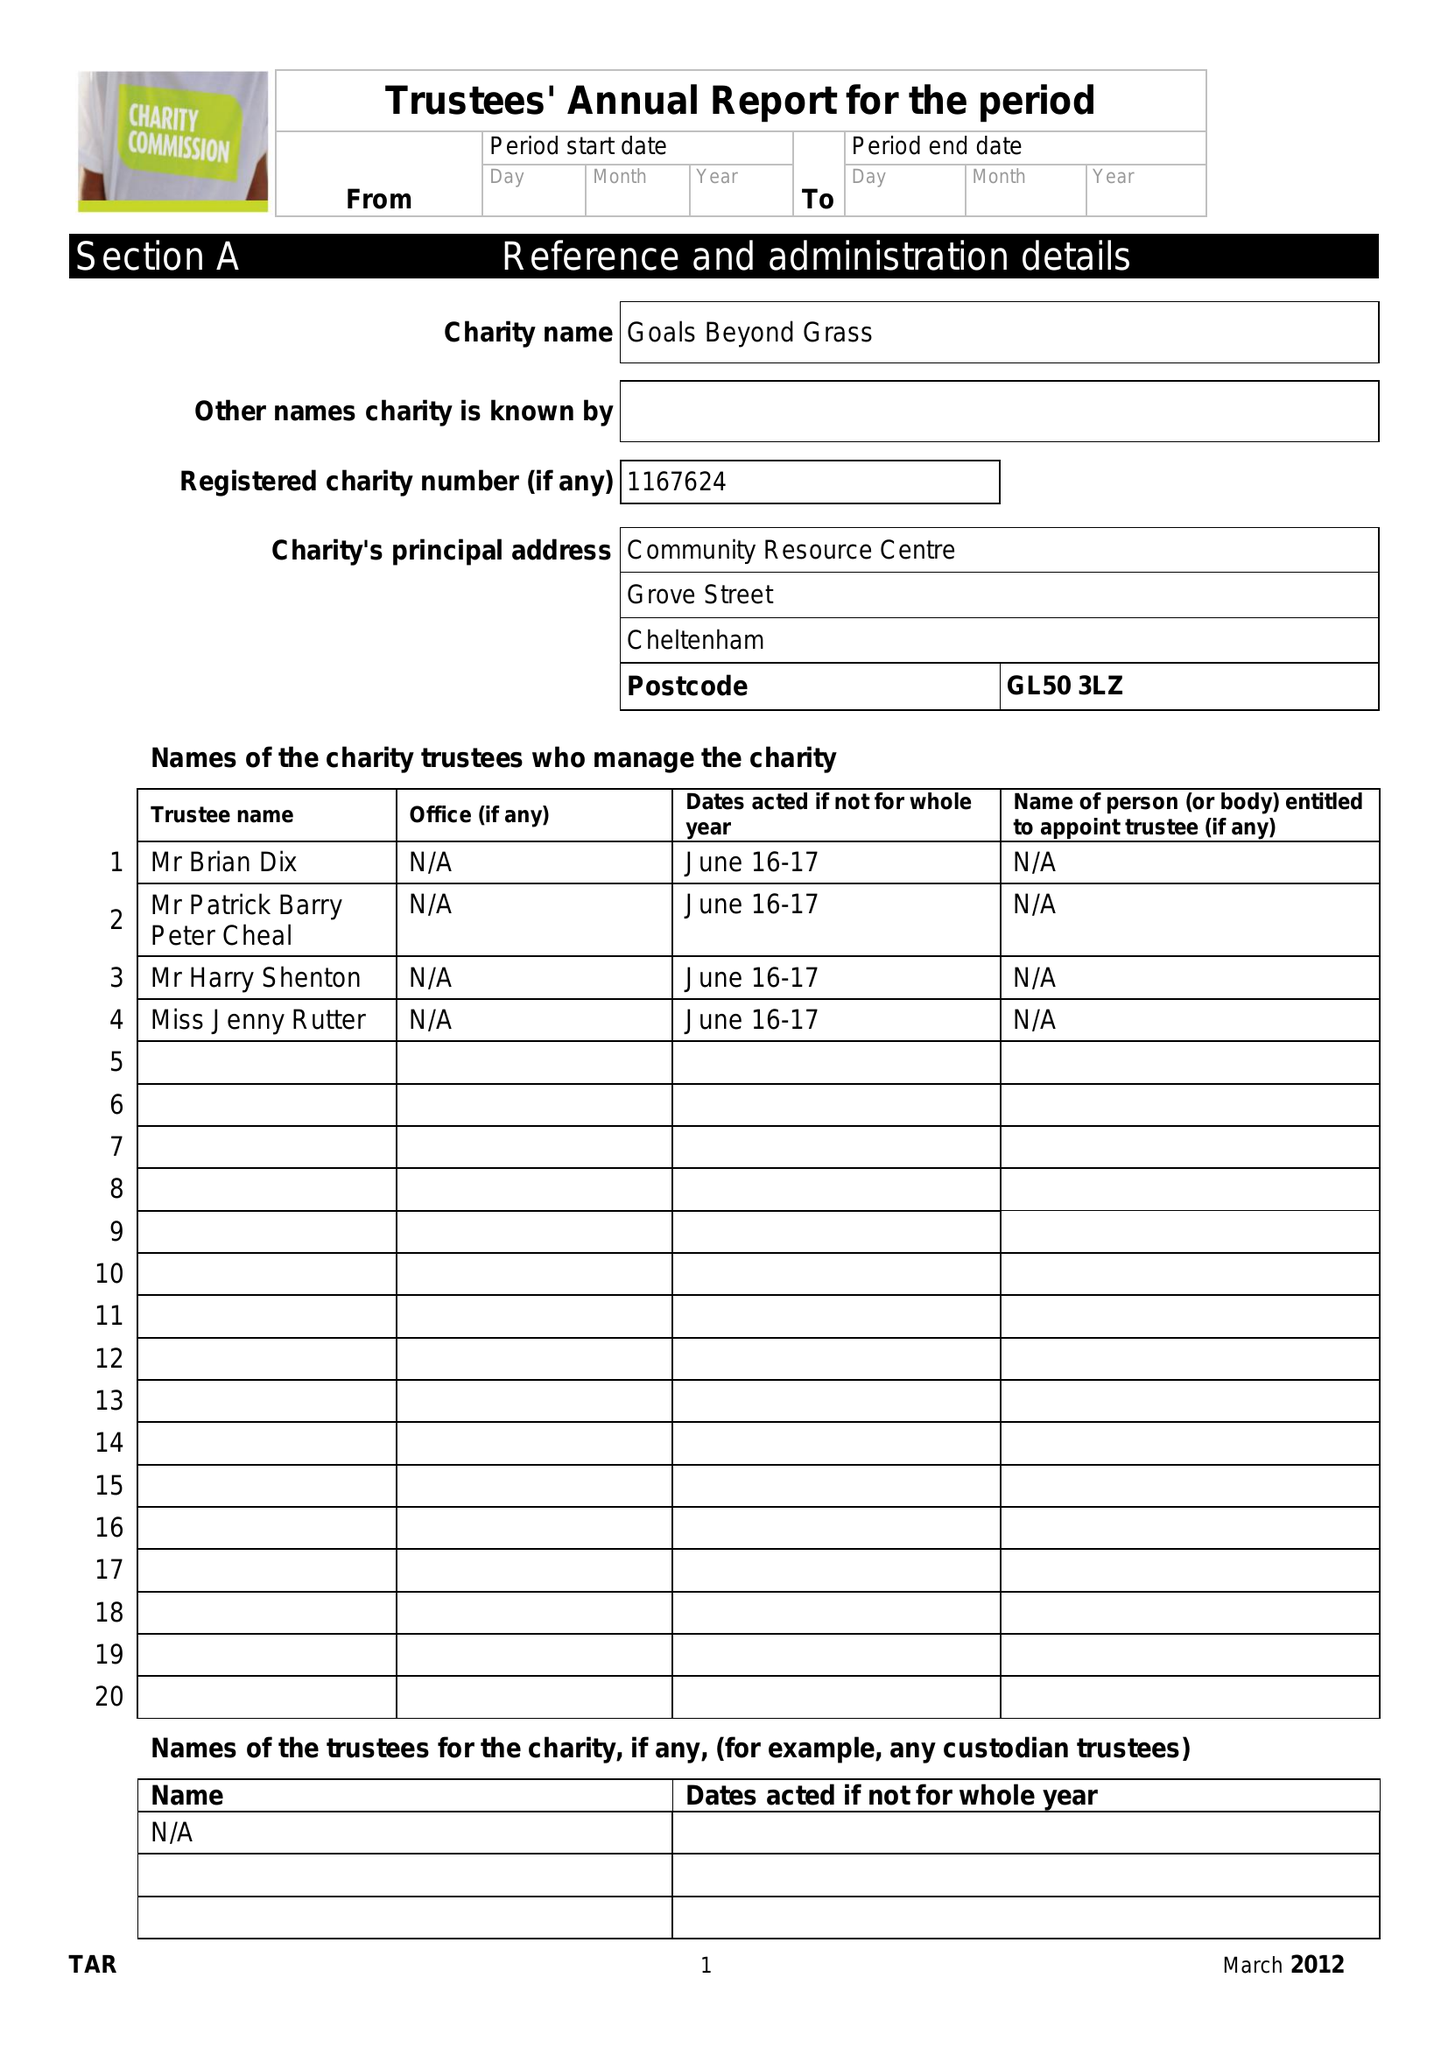What is the value for the spending_annually_in_british_pounds?
Answer the question using a single word or phrase. 29133.00 